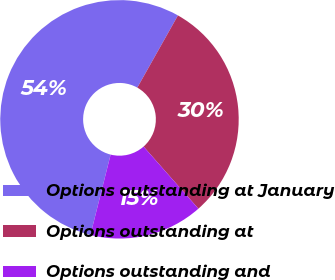Convert chart. <chart><loc_0><loc_0><loc_500><loc_500><pie_chart><fcel>Options outstanding at January<fcel>Options outstanding at<fcel>Options outstanding and<nl><fcel>54.24%<fcel>30.33%<fcel>15.43%<nl></chart> 